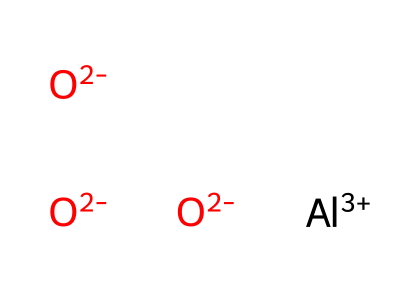What is the central atom in this chemical structure? The structure indicates that aluminum is present in a +3 oxidation state, which is denoted by the notation [Al+3]. Therefore, aluminum is the central atom in the composition.
Answer: aluminum How many oxygen atoms are present in this chemical? By analyzing the SMILES representation, there are three instances of oxygen represented as [O-2], which indicates that there are three oxygen atoms in the structure.
Answer: three What is the total charge of the chemical structure? The aluminum contributes a +3 charge, while each of the three oxygen atoms contributes a -2 charge, totaling a -6 charge. Therefore, the overall charge is +3 (from Al) - 6 (from O) which equals -3.
Answer: -3 What type of bonding is present between aluminum and oxygen? The aluminum atom and the oxygen atoms form ionic bonds. The aluminum, being a metal, gives up electrons, while the oxygen atoms, being non-metals, accept them, resulting in ionic interactions.
Answer: ionic What is the common name for this compound in ceramics? In ceramics, this compound, consisting of aluminum and oxygen, is universally referred to as alumina.
Answer: alumina What makes aluminum oxide suitable for use in ceramic horseshoes? Aluminum oxide is known for its high strength and durability, which makes it ideal for the demanding conditions of racing and training environments. Additionally, it has excellent wear resistance and thermal stability.
Answer: high strength and durability 